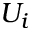<formula> <loc_0><loc_0><loc_500><loc_500>U _ { i }</formula> 